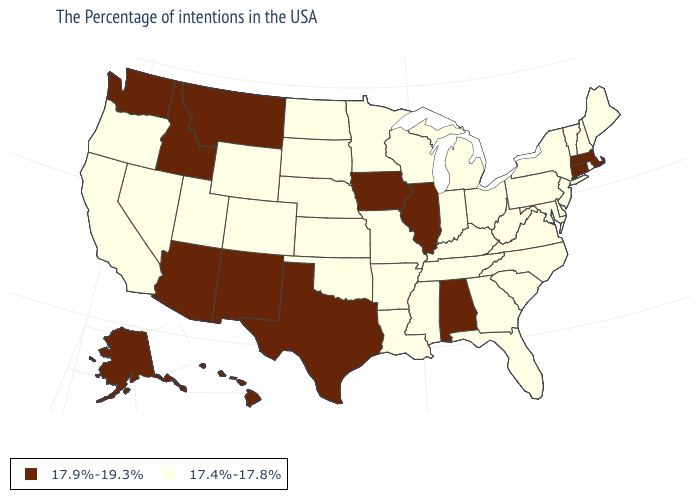Among the states that border Missouri , does Kansas have the highest value?
Answer briefly. No. Name the states that have a value in the range 17.4%-17.8%?
Be succinct. Maine, Rhode Island, New Hampshire, Vermont, New York, New Jersey, Delaware, Maryland, Pennsylvania, Virginia, North Carolina, South Carolina, West Virginia, Ohio, Florida, Georgia, Michigan, Kentucky, Indiana, Tennessee, Wisconsin, Mississippi, Louisiana, Missouri, Arkansas, Minnesota, Kansas, Nebraska, Oklahoma, South Dakota, North Dakota, Wyoming, Colorado, Utah, Nevada, California, Oregon. What is the value of Alaska?
Concise answer only. 17.9%-19.3%. Does Illinois have the lowest value in the USA?
Write a very short answer. No. Does Virginia have the highest value in the South?
Write a very short answer. No. Name the states that have a value in the range 17.9%-19.3%?
Keep it brief. Massachusetts, Connecticut, Alabama, Illinois, Iowa, Texas, New Mexico, Montana, Arizona, Idaho, Washington, Alaska, Hawaii. Does New Mexico have the lowest value in the USA?
Write a very short answer. No. What is the value of Michigan?
Give a very brief answer. 17.4%-17.8%. Does New York have the same value as Louisiana?
Be succinct. Yes. Name the states that have a value in the range 17.9%-19.3%?
Write a very short answer. Massachusetts, Connecticut, Alabama, Illinois, Iowa, Texas, New Mexico, Montana, Arizona, Idaho, Washington, Alaska, Hawaii. What is the value of North Carolina?
Give a very brief answer. 17.4%-17.8%. Name the states that have a value in the range 17.9%-19.3%?
Answer briefly. Massachusetts, Connecticut, Alabama, Illinois, Iowa, Texas, New Mexico, Montana, Arizona, Idaho, Washington, Alaska, Hawaii. Does Iowa have the lowest value in the MidWest?
Concise answer only. No. 